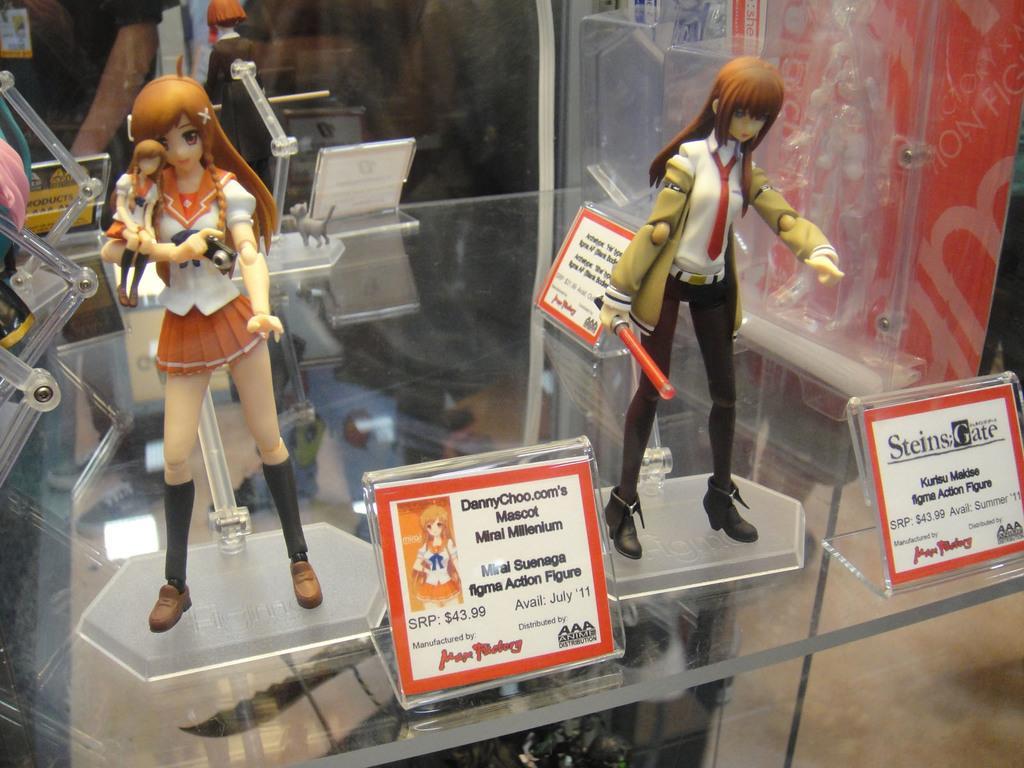How would you summarize this image in a sentence or two? In this image I can see the toys on the glass table. I can also see the boards with some text written on it. In the background, I can see a person. 